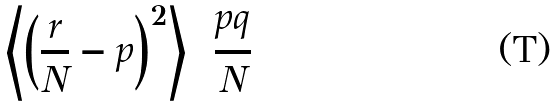Convert formula to latex. <formula><loc_0><loc_0><loc_500><loc_500>\left \langle \left ( \frac { r } { N } - p \right ) ^ { 2 } \right \rangle = \frac { p q } { N }</formula> 